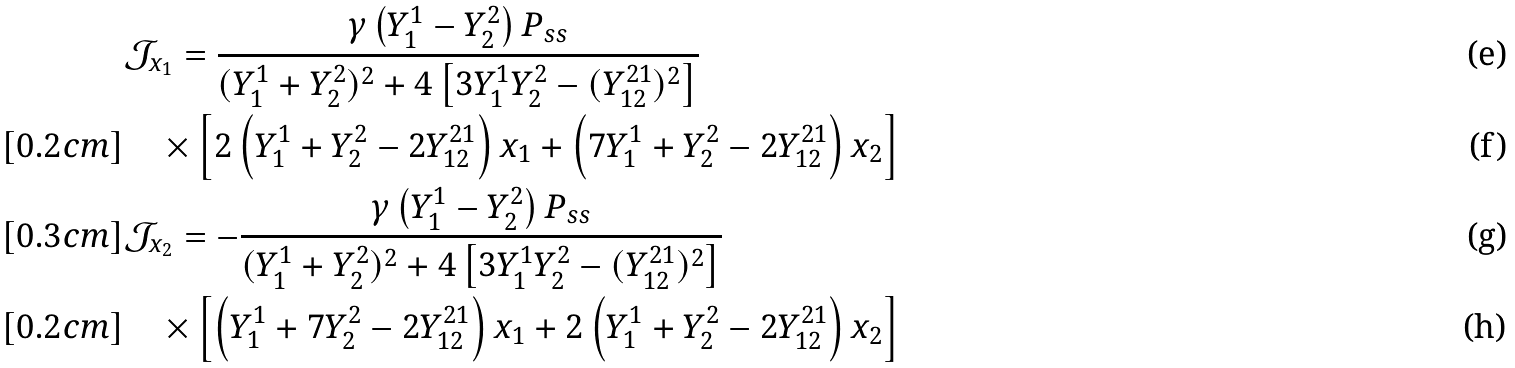Convert formula to latex. <formula><loc_0><loc_0><loc_500><loc_500>& \mathcal { J } _ { x _ { 1 } } = \frac { \gamma \left ( Y _ { 1 } ^ { 1 } - Y _ { 2 } ^ { 2 } \right ) P _ { s s } } { ( Y _ { 1 } ^ { 1 } + Y _ { 2 } ^ { 2 } ) ^ { 2 } + 4 \left [ 3 Y _ { 1 } ^ { 1 } Y _ { 2 } ^ { 2 } - ( Y _ { 1 2 } ^ { 2 1 } ) ^ { 2 } \right ] } \\ [ 0 . 2 c m ] & \quad \times \left [ 2 \left ( Y _ { 1 } ^ { 1 } + Y _ { 2 } ^ { 2 } - 2 Y _ { 1 2 } ^ { 2 1 } \right ) x _ { 1 } + \left ( 7 Y _ { 1 } ^ { 1 } + Y _ { 2 } ^ { 2 } - 2 Y _ { 1 2 } ^ { 2 1 } \right ) x _ { 2 } \right ] \\ [ 0 . 3 c m ] & \mathcal { J } _ { x _ { 2 } } = - \frac { \gamma \left ( Y _ { 1 } ^ { 1 } - Y _ { 2 } ^ { 2 } \right ) P _ { s s } } { ( Y _ { 1 } ^ { 1 } + Y _ { 2 } ^ { 2 } ) ^ { 2 } + 4 \left [ 3 Y _ { 1 } ^ { 1 } Y _ { 2 } ^ { 2 } - ( Y _ { 1 2 } ^ { 2 1 } ) ^ { 2 } \right ] } \\ [ 0 . 2 c m ] & \quad \times \left [ \left ( Y _ { 1 } ^ { 1 } + 7 Y _ { 2 } ^ { 2 } - 2 Y _ { 1 2 } ^ { 2 1 } \right ) x _ { 1 } + 2 \left ( Y _ { 1 } ^ { 1 } + Y _ { 2 } ^ { 2 } - 2 Y _ { 1 2 } ^ { 2 1 } \right ) x _ { 2 } \right ]</formula> 